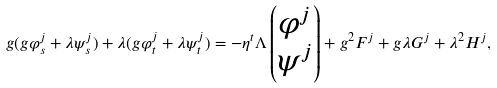<formula> <loc_0><loc_0><loc_500><loc_500>g ( g \varphi ^ { j } _ { s } + \lambda \psi ^ { j } _ { s } ) + \lambda ( g \varphi ^ { j } _ { t } + \lambda \psi ^ { j } _ { t } ) = - \eta ^ { t } \Lambda \begin{pmatrix} \varphi ^ { j } \\ \psi ^ { j } \end{pmatrix} + g ^ { 2 } F ^ { j } + g \lambda G ^ { j } + \lambda ^ { 2 } H ^ { j } ,</formula> 